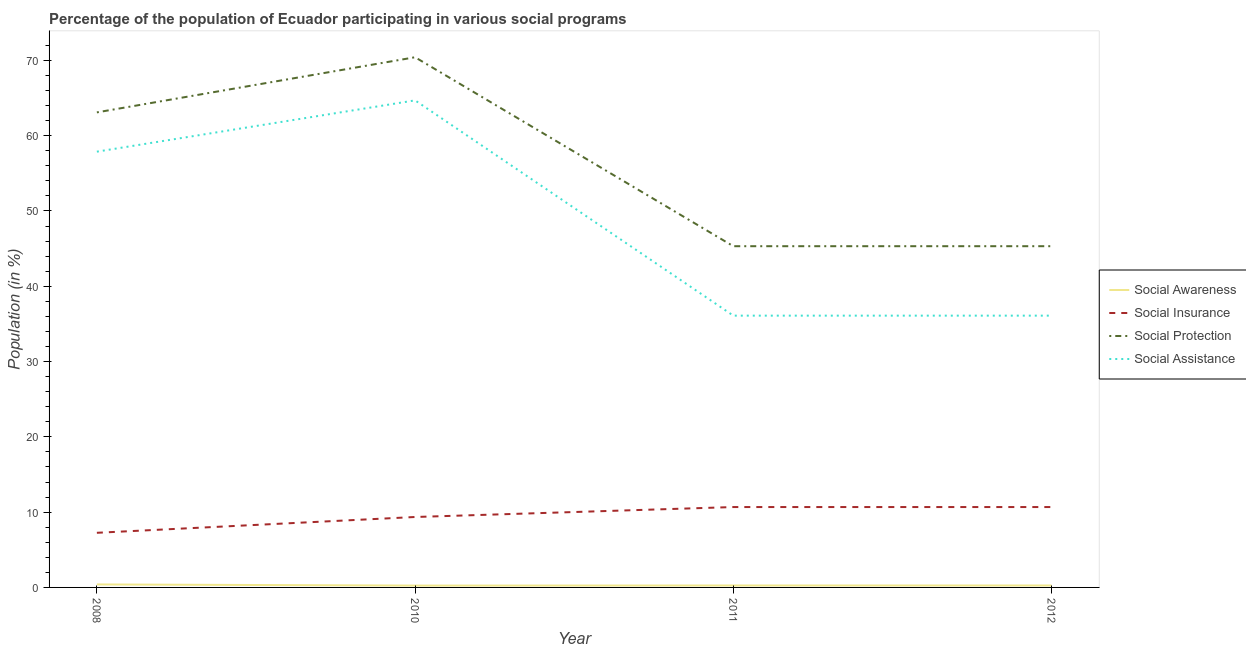Does the line corresponding to participation of population in social awareness programs intersect with the line corresponding to participation of population in social assistance programs?
Provide a succinct answer. No. What is the participation of population in social assistance programs in 2010?
Your answer should be very brief. 64.69. Across all years, what is the maximum participation of population in social protection programs?
Keep it short and to the point. 70.42. Across all years, what is the minimum participation of population in social assistance programs?
Your answer should be compact. 36.1. In which year was the participation of population in social awareness programs minimum?
Your answer should be compact. 2010. What is the total participation of population in social insurance programs in the graph?
Your answer should be very brief. 37.96. What is the difference between the participation of population in social protection programs in 2011 and that in 2012?
Your response must be concise. 0. What is the difference between the participation of population in social protection programs in 2012 and the participation of population in social awareness programs in 2008?
Keep it short and to the point. 44.92. What is the average participation of population in social awareness programs per year?
Your response must be concise. 0.29. In the year 2012, what is the difference between the participation of population in social awareness programs and participation of population in social insurance programs?
Offer a terse response. -10.42. Is the difference between the participation of population in social insurance programs in 2011 and 2012 greater than the difference between the participation of population in social protection programs in 2011 and 2012?
Keep it short and to the point. No. What is the difference between the highest and the second highest participation of population in social awareness programs?
Make the answer very short. 0.14. What is the difference between the highest and the lowest participation of population in social insurance programs?
Make the answer very short. 3.42. In how many years, is the participation of population in social protection programs greater than the average participation of population in social protection programs taken over all years?
Ensure brevity in your answer.  2. Is the sum of the participation of population in social assistance programs in 2011 and 2012 greater than the maximum participation of population in social awareness programs across all years?
Your response must be concise. Yes. Is it the case that in every year, the sum of the participation of population in social awareness programs and participation of population in social insurance programs is greater than the participation of population in social protection programs?
Ensure brevity in your answer.  No. Does the participation of population in social protection programs monotonically increase over the years?
Ensure brevity in your answer.  No. Is the participation of population in social protection programs strictly greater than the participation of population in social assistance programs over the years?
Keep it short and to the point. Yes. Is the participation of population in social awareness programs strictly less than the participation of population in social assistance programs over the years?
Offer a very short reply. Yes. How many lines are there?
Make the answer very short. 4. How many legend labels are there?
Give a very brief answer. 4. How are the legend labels stacked?
Your answer should be very brief. Vertical. What is the title of the graph?
Make the answer very short. Percentage of the population of Ecuador participating in various social programs . Does "PFC gas" appear as one of the legend labels in the graph?
Keep it short and to the point. No. What is the label or title of the X-axis?
Give a very brief answer. Year. What is the label or title of the Y-axis?
Your answer should be very brief. Population (in %). What is the Population (in %) in Social Awareness in 2008?
Your answer should be very brief. 0.4. What is the Population (in %) of Social Insurance in 2008?
Provide a short and direct response. 7.26. What is the Population (in %) of Social Protection in 2008?
Offer a terse response. 63.09. What is the Population (in %) of Social Assistance in 2008?
Offer a terse response. 57.88. What is the Population (in %) in Social Awareness in 2010?
Make the answer very short. 0.25. What is the Population (in %) of Social Insurance in 2010?
Provide a succinct answer. 9.35. What is the Population (in %) of Social Protection in 2010?
Give a very brief answer. 70.42. What is the Population (in %) in Social Assistance in 2010?
Offer a terse response. 64.69. What is the Population (in %) in Social Awareness in 2011?
Your answer should be very brief. 0.26. What is the Population (in %) of Social Insurance in 2011?
Provide a short and direct response. 10.67. What is the Population (in %) of Social Protection in 2011?
Make the answer very short. 45.32. What is the Population (in %) in Social Assistance in 2011?
Make the answer very short. 36.1. What is the Population (in %) in Social Awareness in 2012?
Your response must be concise. 0.26. What is the Population (in %) in Social Insurance in 2012?
Provide a succinct answer. 10.67. What is the Population (in %) in Social Protection in 2012?
Your response must be concise. 45.32. What is the Population (in %) of Social Assistance in 2012?
Ensure brevity in your answer.  36.1. Across all years, what is the maximum Population (in %) in Social Awareness?
Offer a very short reply. 0.4. Across all years, what is the maximum Population (in %) of Social Insurance?
Provide a succinct answer. 10.67. Across all years, what is the maximum Population (in %) in Social Protection?
Provide a short and direct response. 70.42. Across all years, what is the maximum Population (in %) of Social Assistance?
Your answer should be compact. 64.69. Across all years, what is the minimum Population (in %) in Social Awareness?
Your answer should be very brief. 0.25. Across all years, what is the minimum Population (in %) of Social Insurance?
Keep it short and to the point. 7.26. Across all years, what is the minimum Population (in %) in Social Protection?
Give a very brief answer. 45.32. Across all years, what is the minimum Population (in %) in Social Assistance?
Your answer should be very brief. 36.1. What is the total Population (in %) of Social Awareness in the graph?
Keep it short and to the point. 1.16. What is the total Population (in %) of Social Insurance in the graph?
Make the answer very short. 37.96. What is the total Population (in %) of Social Protection in the graph?
Your response must be concise. 224.15. What is the total Population (in %) in Social Assistance in the graph?
Your answer should be compact. 194.76. What is the difference between the Population (in %) in Social Awareness in 2008 and that in 2010?
Make the answer very short. 0.15. What is the difference between the Population (in %) of Social Insurance in 2008 and that in 2010?
Provide a short and direct response. -2.1. What is the difference between the Population (in %) of Social Protection in 2008 and that in 2010?
Make the answer very short. -7.32. What is the difference between the Population (in %) in Social Assistance in 2008 and that in 2010?
Your answer should be compact. -6.81. What is the difference between the Population (in %) in Social Awareness in 2008 and that in 2011?
Make the answer very short. 0.14. What is the difference between the Population (in %) of Social Insurance in 2008 and that in 2011?
Your answer should be compact. -3.42. What is the difference between the Population (in %) in Social Protection in 2008 and that in 2011?
Give a very brief answer. 17.77. What is the difference between the Population (in %) of Social Assistance in 2008 and that in 2011?
Your response must be concise. 21.78. What is the difference between the Population (in %) of Social Awareness in 2008 and that in 2012?
Keep it short and to the point. 0.14. What is the difference between the Population (in %) in Social Insurance in 2008 and that in 2012?
Your answer should be very brief. -3.42. What is the difference between the Population (in %) of Social Protection in 2008 and that in 2012?
Make the answer very short. 17.77. What is the difference between the Population (in %) of Social Assistance in 2008 and that in 2012?
Provide a succinct answer. 21.78. What is the difference between the Population (in %) in Social Awareness in 2010 and that in 2011?
Make the answer very short. -0.01. What is the difference between the Population (in %) in Social Insurance in 2010 and that in 2011?
Ensure brevity in your answer.  -1.32. What is the difference between the Population (in %) of Social Protection in 2010 and that in 2011?
Your answer should be compact. 25.1. What is the difference between the Population (in %) of Social Assistance in 2010 and that in 2011?
Provide a succinct answer. 28.59. What is the difference between the Population (in %) in Social Awareness in 2010 and that in 2012?
Your response must be concise. -0.01. What is the difference between the Population (in %) of Social Insurance in 2010 and that in 2012?
Give a very brief answer. -1.32. What is the difference between the Population (in %) in Social Protection in 2010 and that in 2012?
Give a very brief answer. 25.1. What is the difference between the Population (in %) of Social Assistance in 2010 and that in 2012?
Your answer should be compact. 28.59. What is the difference between the Population (in %) in Social Insurance in 2011 and that in 2012?
Keep it short and to the point. 0. What is the difference between the Population (in %) of Social Assistance in 2011 and that in 2012?
Offer a very short reply. 0. What is the difference between the Population (in %) of Social Awareness in 2008 and the Population (in %) of Social Insurance in 2010?
Give a very brief answer. -8.96. What is the difference between the Population (in %) of Social Awareness in 2008 and the Population (in %) of Social Protection in 2010?
Keep it short and to the point. -70.02. What is the difference between the Population (in %) of Social Awareness in 2008 and the Population (in %) of Social Assistance in 2010?
Offer a terse response. -64.29. What is the difference between the Population (in %) of Social Insurance in 2008 and the Population (in %) of Social Protection in 2010?
Provide a short and direct response. -63.16. What is the difference between the Population (in %) in Social Insurance in 2008 and the Population (in %) in Social Assistance in 2010?
Offer a very short reply. -57.43. What is the difference between the Population (in %) in Social Protection in 2008 and the Population (in %) in Social Assistance in 2010?
Your response must be concise. -1.6. What is the difference between the Population (in %) in Social Awareness in 2008 and the Population (in %) in Social Insurance in 2011?
Ensure brevity in your answer.  -10.28. What is the difference between the Population (in %) in Social Awareness in 2008 and the Population (in %) in Social Protection in 2011?
Your answer should be very brief. -44.92. What is the difference between the Population (in %) of Social Awareness in 2008 and the Population (in %) of Social Assistance in 2011?
Your response must be concise. -35.7. What is the difference between the Population (in %) of Social Insurance in 2008 and the Population (in %) of Social Protection in 2011?
Make the answer very short. -38.07. What is the difference between the Population (in %) in Social Insurance in 2008 and the Population (in %) in Social Assistance in 2011?
Your answer should be very brief. -28.84. What is the difference between the Population (in %) of Social Protection in 2008 and the Population (in %) of Social Assistance in 2011?
Your response must be concise. 26.99. What is the difference between the Population (in %) in Social Awareness in 2008 and the Population (in %) in Social Insurance in 2012?
Give a very brief answer. -10.28. What is the difference between the Population (in %) in Social Awareness in 2008 and the Population (in %) in Social Protection in 2012?
Offer a very short reply. -44.92. What is the difference between the Population (in %) of Social Awareness in 2008 and the Population (in %) of Social Assistance in 2012?
Your response must be concise. -35.7. What is the difference between the Population (in %) of Social Insurance in 2008 and the Population (in %) of Social Protection in 2012?
Give a very brief answer. -38.07. What is the difference between the Population (in %) in Social Insurance in 2008 and the Population (in %) in Social Assistance in 2012?
Provide a succinct answer. -28.84. What is the difference between the Population (in %) in Social Protection in 2008 and the Population (in %) in Social Assistance in 2012?
Make the answer very short. 26.99. What is the difference between the Population (in %) in Social Awareness in 2010 and the Population (in %) in Social Insurance in 2011?
Ensure brevity in your answer.  -10.43. What is the difference between the Population (in %) in Social Awareness in 2010 and the Population (in %) in Social Protection in 2011?
Your answer should be very brief. -45.07. What is the difference between the Population (in %) in Social Awareness in 2010 and the Population (in %) in Social Assistance in 2011?
Give a very brief answer. -35.85. What is the difference between the Population (in %) in Social Insurance in 2010 and the Population (in %) in Social Protection in 2011?
Make the answer very short. -35.97. What is the difference between the Population (in %) of Social Insurance in 2010 and the Population (in %) of Social Assistance in 2011?
Give a very brief answer. -26.74. What is the difference between the Population (in %) in Social Protection in 2010 and the Population (in %) in Social Assistance in 2011?
Ensure brevity in your answer.  34.32. What is the difference between the Population (in %) of Social Awareness in 2010 and the Population (in %) of Social Insurance in 2012?
Provide a short and direct response. -10.43. What is the difference between the Population (in %) in Social Awareness in 2010 and the Population (in %) in Social Protection in 2012?
Offer a terse response. -45.07. What is the difference between the Population (in %) of Social Awareness in 2010 and the Population (in %) of Social Assistance in 2012?
Provide a succinct answer. -35.85. What is the difference between the Population (in %) of Social Insurance in 2010 and the Population (in %) of Social Protection in 2012?
Offer a very short reply. -35.97. What is the difference between the Population (in %) of Social Insurance in 2010 and the Population (in %) of Social Assistance in 2012?
Offer a terse response. -26.74. What is the difference between the Population (in %) of Social Protection in 2010 and the Population (in %) of Social Assistance in 2012?
Keep it short and to the point. 34.32. What is the difference between the Population (in %) of Social Awareness in 2011 and the Population (in %) of Social Insurance in 2012?
Give a very brief answer. -10.42. What is the difference between the Population (in %) in Social Awareness in 2011 and the Population (in %) in Social Protection in 2012?
Ensure brevity in your answer.  -45.06. What is the difference between the Population (in %) of Social Awareness in 2011 and the Population (in %) of Social Assistance in 2012?
Your answer should be compact. -35.84. What is the difference between the Population (in %) in Social Insurance in 2011 and the Population (in %) in Social Protection in 2012?
Ensure brevity in your answer.  -34.65. What is the difference between the Population (in %) in Social Insurance in 2011 and the Population (in %) in Social Assistance in 2012?
Ensure brevity in your answer.  -25.42. What is the difference between the Population (in %) in Social Protection in 2011 and the Population (in %) in Social Assistance in 2012?
Ensure brevity in your answer.  9.22. What is the average Population (in %) of Social Awareness per year?
Offer a very short reply. 0.29. What is the average Population (in %) in Social Insurance per year?
Give a very brief answer. 9.49. What is the average Population (in %) in Social Protection per year?
Provide a short and direct response. 56.04. What is the average Population (in %) of Social Assistance per year?
Give a very brief answer. 48.69. In the year 2008, what is the difference between the Population (in %) in Social Awareness and Population (in %) in Social Insurance?
Your answer should be compact. -6.86. In the year 2008, what is the difference between the Population (in %) in Social Awareness and Population (in %) in Social Protection?
Your answer should be compact. -62.7. In the year 2008, what is the difference between the Population (in %) in Social Awareness and Population (in %) in Social Assistance?
Offer a terse response. -57.48. In the year 2008, what is the difference between the Population (in %) in Social Insurance and Population (in %) in Social Protection?
Keep it short and to the point. -55.84. In the year 2008, what is the difference between the Population (in %) in Social Insurance and Population (in %) in Social Assistance?
Offer a very short reply. -50.62. In the year 2008, what is the difference between the Population (in %) of Social Protection and Population (in %) of Social Assistance?
Keep it short and to the point. 5.22. In the year 2010, what is the difference between the Population (in %) in Social Awareness and Population (in %) in Social Insurance?
Offer a terse response. -9.11. In the year 2010, what is the difference between the Population (in %) in Social Awareness and Population (in %) in Social Protection?
Keep it short and to the point. -70.17. In the year 2010, what is the difference between the Population (in %) in Social Awareness and Population (in %) in Social Assistance?
Make the answer very short. -64.44. In the year 2010, what is the difference between the Population (in %) in Social Insurance and Population (in %) in Social Protection?
Provide a succinct answer. -61.06. In the year 2010, what is the difference between the Population (in %) in Social Insurance and Population (in %) in Social Assistance?
Make the answer very short. -55.33. In the year 2010, what is the difference between the Population (in %) of Social Protection and Population (in %) of Social Assistance?
Keep it short and to the point. 5.73. In the year 2011, what is the difference between the Population (in %) of Social Awareness and Population (in %) of Social Insurance?
Offer a very short reply. -10.42. In the year 2011, what is the difference between the Population (in %) of Social Awareness and Population (in %) of Social Protection?
Offer a very short reply. -45.06. In the year 2011, what is the difference between the Population (in %) in Social Awareness and Population (in %) in Social Assistance?
Your answer should be compact. -35.84. In the year 2011, what is the difference between the Population (in %) of Social Insurance and Population (in %) of Social Protection?
Offer a terse response. -34.65. In the year 2011, what is the difference between the Population (in %) of Social Insurance and Population (in %) of Social Assistance?
Your answer should be very brief. -25.42. In the year 2011, what is the difference between the Population (in %) of Social Protection and Population (in %) of Social Assistance?
Your answer should be compact. 9.22. In the year 2012, what is the difference between the Population (in %) of Social Awareness and Population (in %) of Social Insurance?
Provide a succinct answer. -10.42. In the year 2012, what is the difference between the Population (in %) in Social Awareness and Population (in %) in Social Protection?
Your answer should be very brief. -45.06. In the year 2012, what is the difference between the Population (in %) in Social Awareness and Population (in %) in Social Assistance?
Your answer should be compact. -35.84. In the year 2012, what is the difference between the Population (in %) of Social Insurance and Population (in %) of Social Protection?
Your answer should be very brief. -34.65. In the year 2012, what is the difference between the Population (in %) of Social Insurance and Population (in %) of Social Assistance?
Your response must be concise. -25.42. In the year 2012, what is the difference between the Population (in %) of Social Protection and Population (in %) of Social Assistance?
Offer a very short reply. 9.22. What is the ratio of the Population (in %) in Social Awareness in 2008 to that in 2010?
Your answer should be very brief. 1.62. What is the ratio of the Population (in %) of Social Insurance in 2008 to that in 2010?
Offer a terse response. 0.78. What is the ratio of the Population (in %) of Social Protection in 2008 to that in 2010?
Provide a short and direct response. 0.9. What is the ratio of the Population (in %) in Social Assistance in 2008 to that in 2010?
Provide a short and direct response. 0.89. What is the ratio of the Population (in %) in Social Awareness in 2008 to that in 2011?
Offer a very short reply. 1.55. What is the ratio of the Population (in %) in Social Insurance in 2008 to that in 2011?
Your answer should be very brief. 0.68. What is the ratio of the Population (in %) of Social Protection in 2008 to that in 2011?
Keep it short and to the point. 1.39. What is the ratio of the Population (in %) in Social Assistance in 2008 to that in 2011?
Your response must be concise. 1.6. What is the ratio of the Population (in %) in Social Awareness in 2008 to that in 2012?
Give a very brief answer. 1.55. What is the ratio of the Population (in %) in Social Insurance in 2008 to that in 2012?
Make the answer very short. 0.68. What is the ratio of the Population (in %) of Social Protection in 2008 to that in 2012?
Your answer should be compact. 1.39. What is the ratio of the Population (in %) in Social Assistance in 2008 to that in 2012?
Offer a very short reply. 1.6. What is the ratio of the Population (in %) of Social Awareness in 2010 to that in 2011?
Make the answer very short. 0.96. What is the ratio of the Population (in %) in Social Insurance in 2010 to that in 2011?
Your answer should be very brief. 0.88. What is the ratio of the Population (in %) of Social Protection in 2010 to that in 2011?
Offer a very short reply. 1.55. What is the ratio of the Population (in %) of Social Assistance in 2010 to that in 2011?
Make the answer very short. 1.79. What is the ratio of the Population (in %) of Social Awareness in 2010 to that in 2012?
Your answer should be very brief. 0.96. What is the ratio of the Population (in %) in Social Insurance in 2010 to that in 2012?
Give a very brief answer. 0.88. What is the ratio of the Population (in %) in Social Protection in 2010 to that in 2012?
Offer a very short reply. 1.55. What is the ratio of the Population (in %) in Social Assistance in 2010 to that in 2012?
Your answer should be compact. 1.79. What is the ratio of the Population (in %) in Social Insurance in 2011 to that in 2012?
Your answer should be compact. 1. What is the ratio of the Population (in %) of Social Protection in 2011 to that in 2012?
Offer a very short reply. 1. What is the ratio of the Population (in %) in Social Assistance in 2011 to that in 2012?
Keep it short and to the point. 1. What is the difference between the highest and the second highest Population (in %) of Social Awareness?
Provide a short and direct response. 0.14. What is the difference between the highest and the second highest Population (in %) of Social Insurance?
Give a very brief answer. 0. What is the difference between the highest and the second highest Population (in %) in Social Protection?
Offer a terse response. 7.32. What is the difference between the highest and the second highest Population (in %) of Social Assistance?
Your response must be concise. 6.81. What is the difference between the highest and the lowest Population (in %) of Social Awareness?
Ensure brevity in your answer.  0.15. What is the difference between the highest and the lowest Population (in %) of Social Insurance?
Make the answer very short. 3.42. What is the difference between the highest and the lowest Population (in %) of Social Protection?
Offer a very short reply. 25.1. What is the difference between the highest and the lowest Population (in %) in Social Assistance?
Provide a succinct answer. 28.59. 